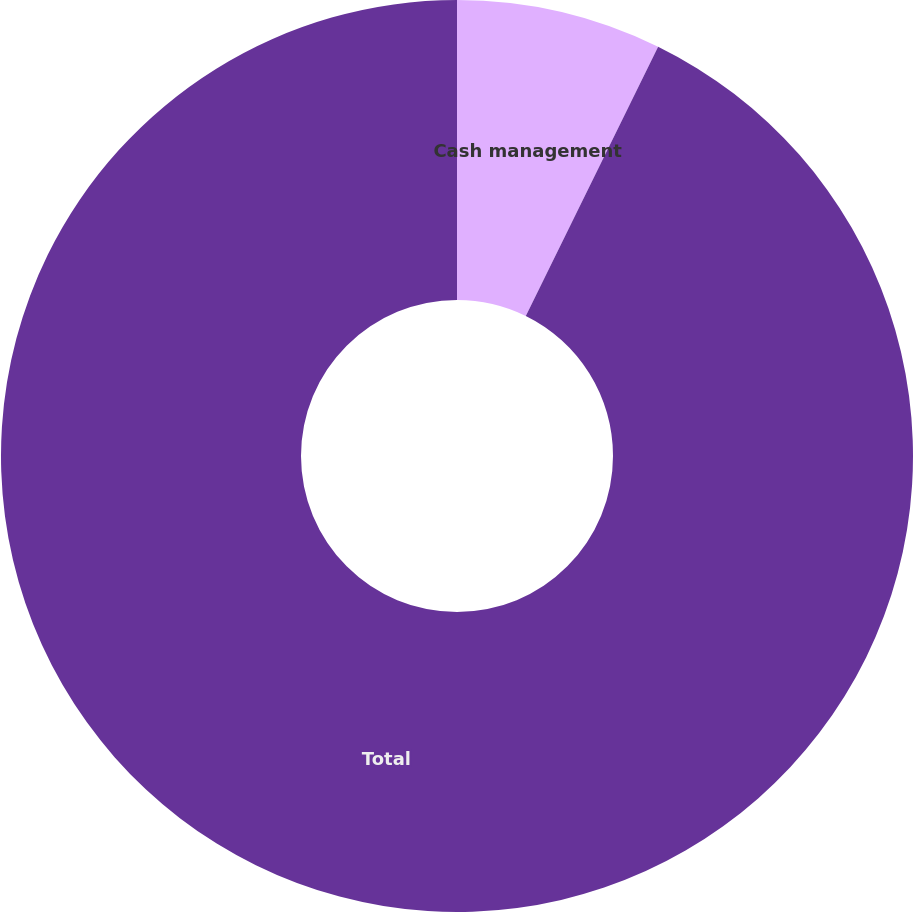Convert chart to OTSL. <chart><loc_0><loc_0><loc_500><loc_500><pie_chart><fcel>Cash management<fcel>Total<nl><fcel>7.27%<fcel>92.73%<nl></chart> 